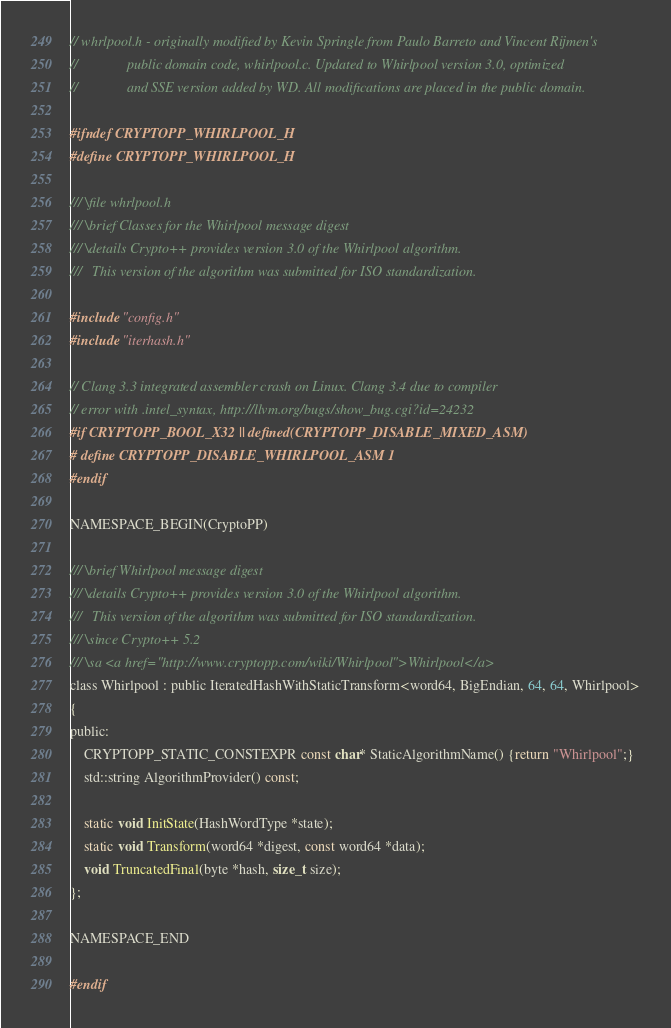<code> <loc_0><loc_0><loc_500><loc_500><_C_>// whrlpool.h - originally modified by Kevin Springle from Paulo Barreto and Vincent Rijmen's
//              public domain code, whirlpool.c. Updated to Whirlpool version 3.0, optimized
//              and SSE version added by WD. All modifications are placed in the public domain.

#ifndef CRYPTOPP_WHIRLPOOL_H
#define CRYPTOPP_WHIRLPOOL_H

/// \file whrlpool.h
/// \brief Classes for the Whirlpool message digest
/// \details Crypto++ provides version 3.0 of the Whirlpool algorithm.
///   This version of the algorithm was submitted for ISO standardization.

#include "config.h"
#include "iterhash.h"

// Clang 3.3 integrated assembler crash on Linux. Clang 3.4 due to compiler
// error with .intel_syntax, http://llvm.org/bugs/show_bug.cgi?id=24232
#if CRYPTOPP_BOOL_X32 || defined(CRYPTOPP_DISABLE_MIXED_ASM)
# define CRYPTOPP_DISABLE_WHIRLPOOL_ASM 1
#endif

NAMESPACE_BEGIN(CryptoPP)

/// \brief Whirlpool message digest
/// \details Crypto++ provides version 3.0 of the Whirlpool algorithm.
///   This version of the algorithm was submitted for ISO standardization.
/// \since Crypto++ 5.2
/// \sa <a href="http://www.cryptopp.com/wiki/Whirlpool">Whirlpool</a>
class Whirlpool : public IteratedHashWithStaticTransform<word64, BigEndian, 64, 64, Whirlpool>
{
public:
	CRYPTOPP_STATIC_CONSTEXPR const char* StaticAlgorithmName() {return "Whirlpool";}
	std::string AlgorithmProvider() const;

	static void InitState(HashWordType *state);
	static void Transform(word64 *digest, const word64 *data);
	void TruncatedFinal(byte *hash, size_t size);
};

NAMESPACE_END

#endif
</code> 